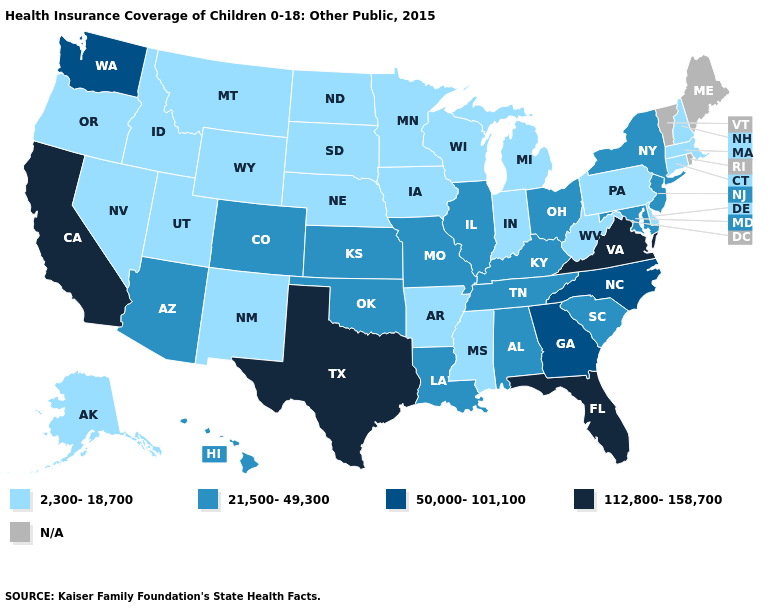What is the value of New Mexico?
Keep it brief. 2,300-18,700. Which states hav the highest value in the West?
Answer briefly. California. Name the states that have a value in the range 112,800-158,700?
Give a very brief answer. California, Florida, Texas, Virginia. What is the value of Illinois?
Be succinct. 21,500-49,300. What is the value of South Carolina?
Be succinct. 21,500-49,300. Among the states that border Missouri , which have the highest value?
Be succinct. Illinois, Kansas, Kentucky, Oklahoma, Tennessee. Is the legend a continuous bar?
Quick response, please. No. Name the states that have a value in the range 50,000-101,100?
Quick response, please. Georgia, North Carolina, Washington. Name the states that have a value in the range 50,000-101,100?
Keep it brief. Georgia, North Carolina, Washington. What is the value of Hawaii?
Quick response, please. 21,500-49,300. Which states have the lowest value in the USA?
Be succinct. Alaska, Arkansas, Connecticut, Delaware, Idaho, Indiana, Iowa, Massachusetts, Michigan, Minnesota, Mississippi, Montana, Nebraska, Nevada, New Hampshire, New Mexico, North Dakota, Oregon, Pennsylvania, South Dakota, Utah, West Virginia, Wisconsin, Wyoming. Does the map have missing data?
Give a very brief answer. Yes. What is the value of Iowa?
Concise answer only. 2,300-18,700. Among the states that border Georgia , which have the highest value?
Write a very short answer. Florida. 